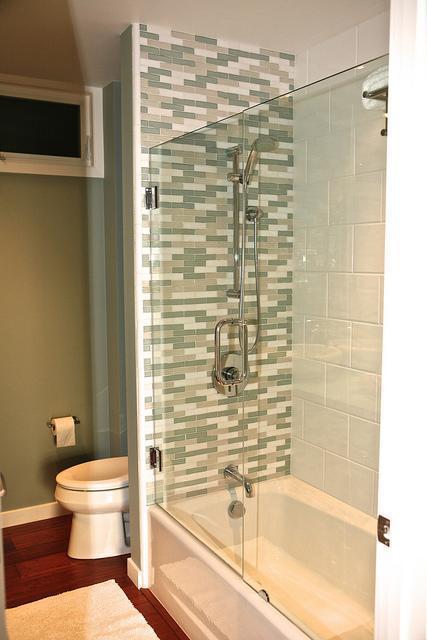How many train cars are on this train?
Give a very brief answer. 0. 